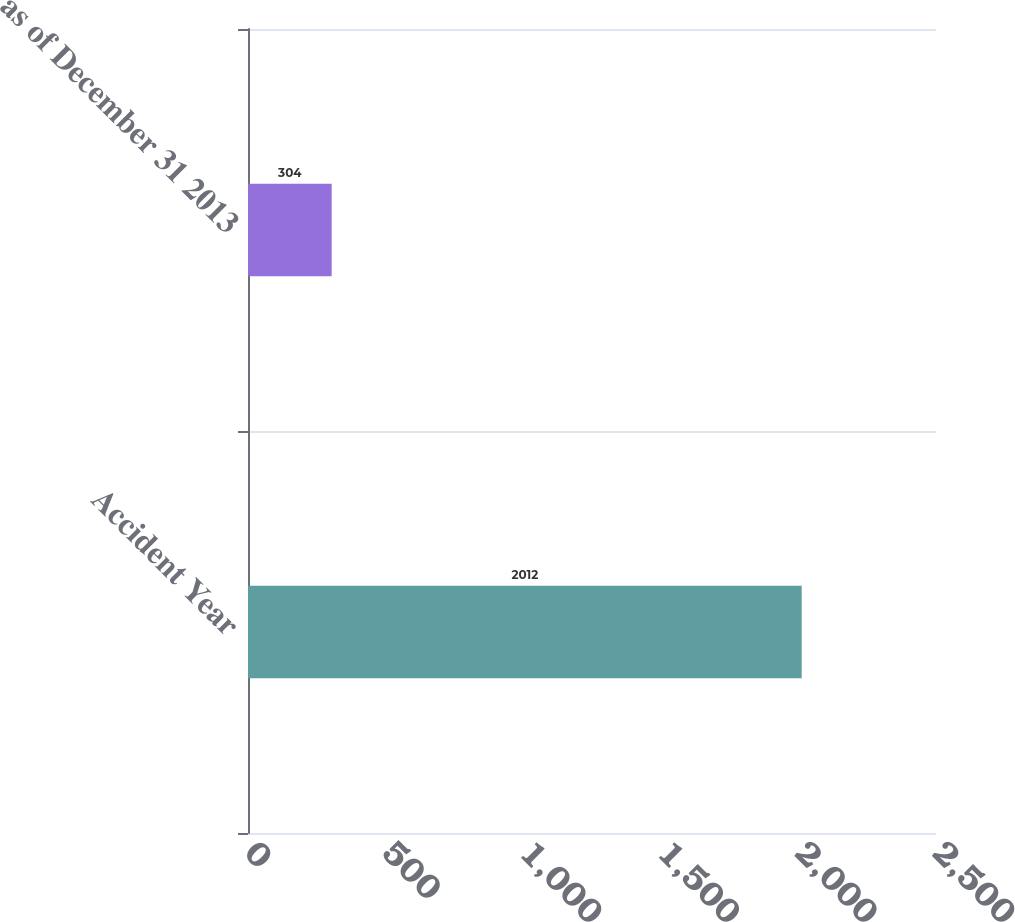Convert chart. <chart><loc_0><loc_0><loc_500><loc_500><bar_chart><fcel>Accident Year<fcel>as of December 31 2013<nl><fcel>2012<fcel>304<nl></chart> 